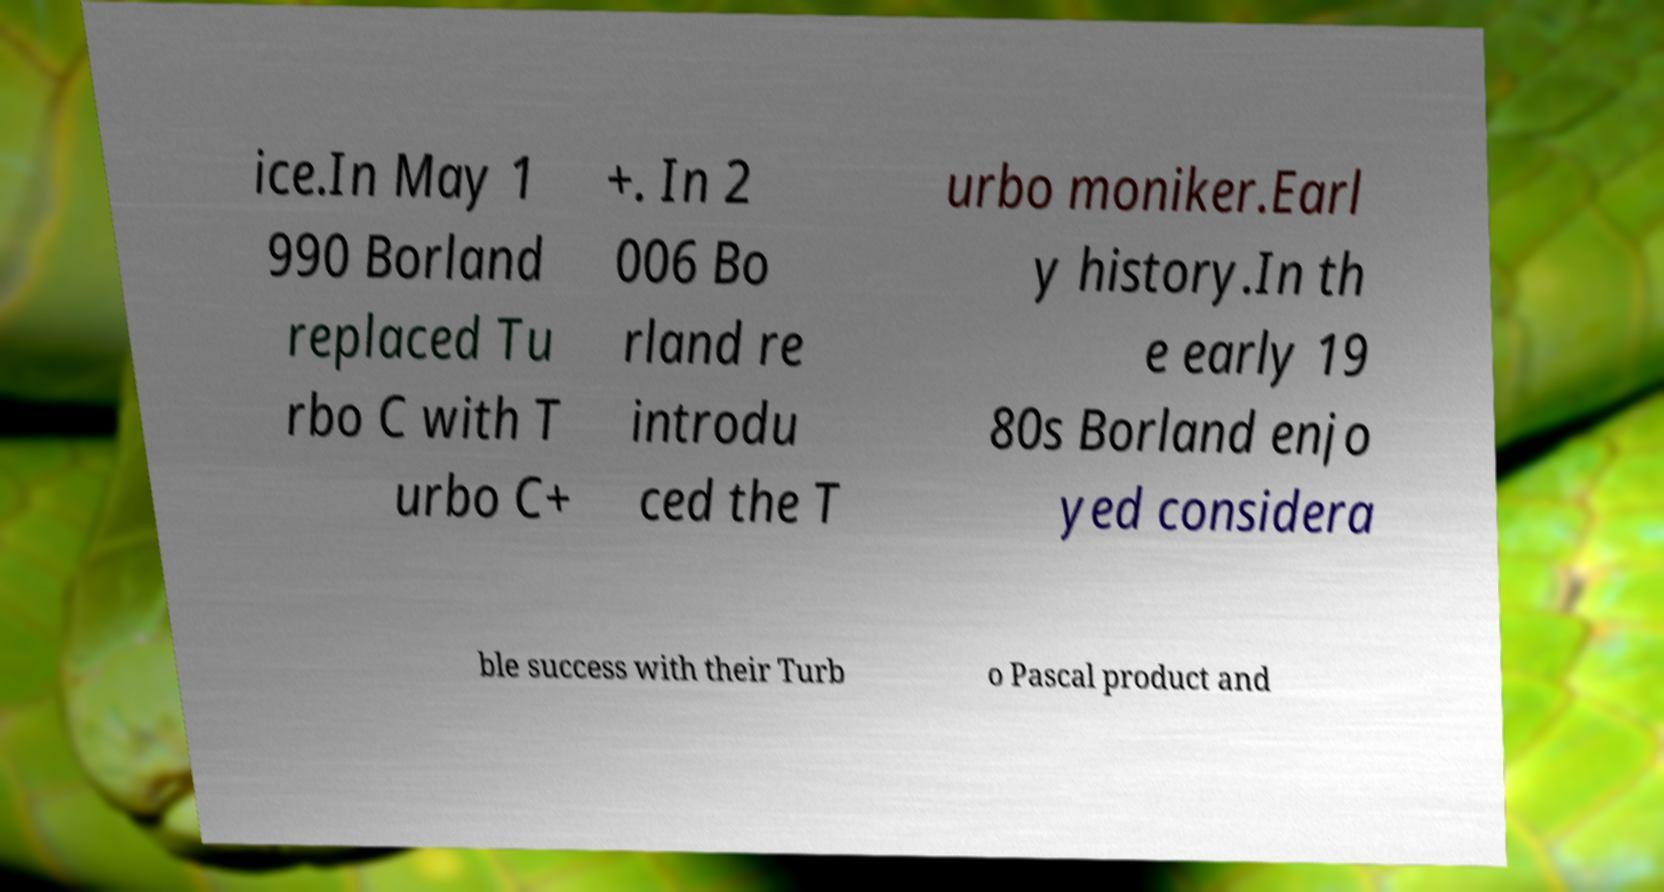I need the written content from this picture converted into text. Can you do that? ice.In May 1 990 Borland replaced Tu rbo C with T urbo C+ +. In 2 006 Bo rland re introdu ced the T urbo moniker.Earl y history.In th e early 19 80s Borland enjo yed considera ble success with their Turb o Pascal product and 